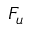<formula> <loc_0><loc_0><loc_500><loc_500>F _ { u }</formula> 